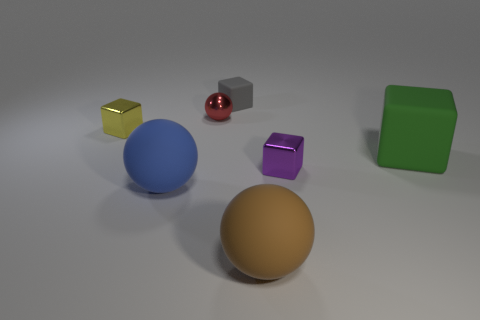How do the objects interact with the lighting in the scene? Observing the lighting interactions in this image is fascinating. The surfaces of the objects vary from matte to shiny, influencing how they reflect light. The golden cube has sharp highlights, revealing its metallic sheen, while the blue sphere features softer, more diffused light, indicating a non-metallic material. The red and purple objects, likely being rubber and plastic, reflect sharper glints of light, and their highlights suggest a more reflective surface. The matte green block absorbs light, showing almost no reflection, which gives it a flatter appearance. Finally, the orange sphere has a textured surface, creating a play of light and shadow that highlights its contours. These interactions help us deduce the material quality and texture of each object. 